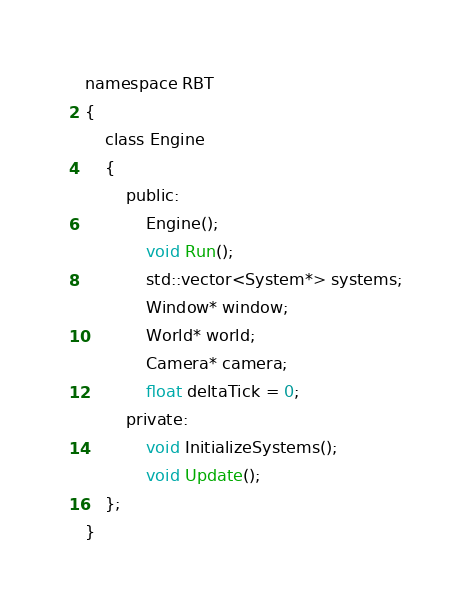Convert code to text. <code><loc_0><loc_0><loc_500><loc_500><_C_>namespace RBT
{
	class Engine
	{
		public:
			Engine();
			void Run();
			std::vector<System*> systems;
			Window* window;
			World* world;
			Camera* camera;
			float deltaTick = 0;
		private:
			void InitializeSystems();
			void Update();
	};
}</code> 